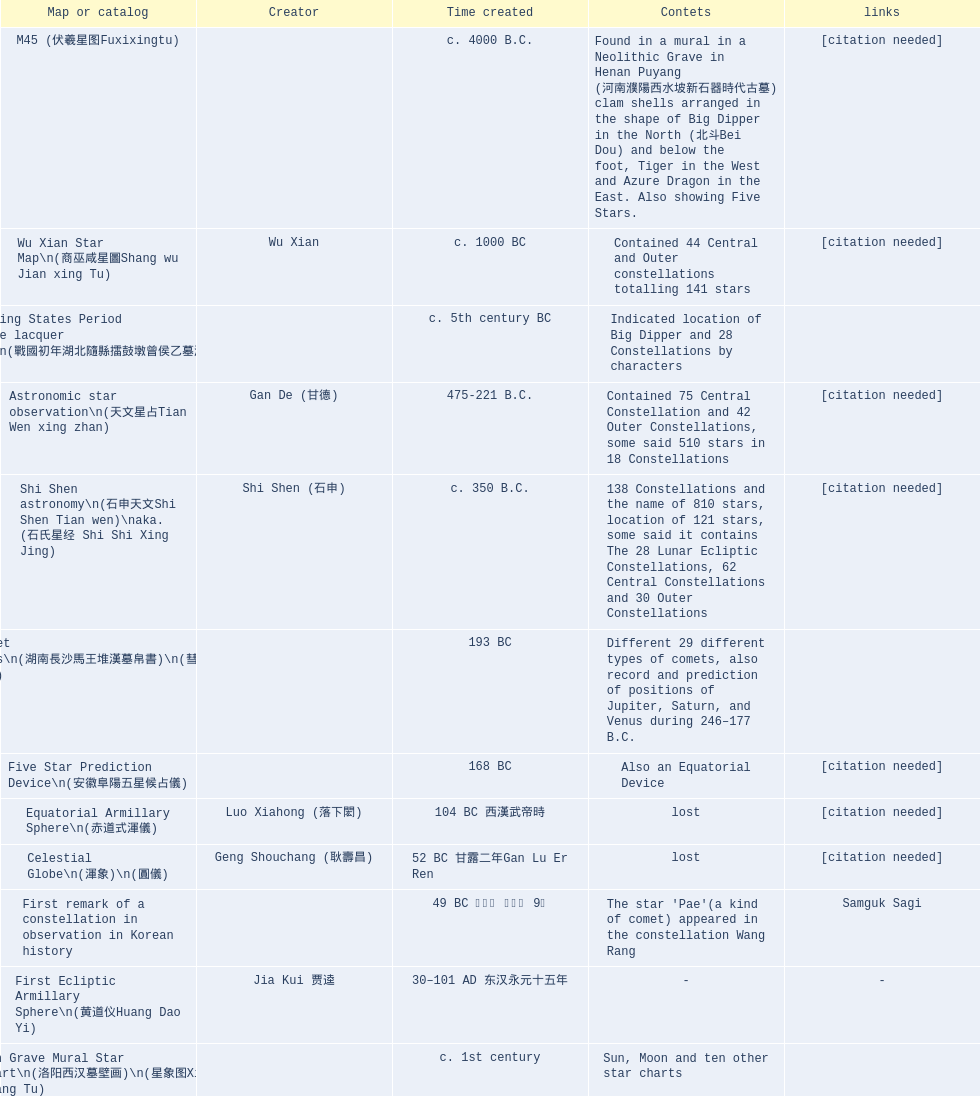Could you parse the entire table? {'header': ['Map or catalog', 'Creator', 'Time created', 'Contets', 'links'], 'rows': [['M45 (伏羲星图Fuxixingtu)', '', 'c. 4000 B.C.', 'Found in a mural in a Neolithic Grave in Henan Puyang (河南濮陽西水坡新石器時代古墓) clam shells arranged in the shape of Big Dipper in the North (北斗Bei Dou) and below the foot, Tiger in the West and Azure Dragon in the East. Also showing Five Stars.', '[citation needed]'], ['Wu Xian Star Map\\n(商巫咸星圖Shang wu Jian xing Tu)', 'Wu Xian', 'c. 1000 BC', 'Contained 44 Central and Outer constellations totalling 141 stars', '[citation needed]'], ['Warring States Period grave lacquer box\\n(戰國初年湖北隨縣擂鼓墩曾侯乙墓漆箱)', '', 'c. 5th century BC', 'Indicated location of Big Dipper and 28 Constellations by characters', ''], ['Astronomic star observation\\n(天文星占Tian Wen xing zhan)', 'Gan De (甘德)', '475-221 B.C.', 'Contained 75 Central Constellation and 42 Outer Constellations, some said 510 stars in 18 Constellations', '[citation needed]'], ['Shi Shen astronomy\\n(石申天文Shi Shen Tian wen)\\naka. (石氏星经 Shi Shi Xing Jing)', 'Shi Shen (石申)', 'c. 350 B.C.', '138 Constellations and the name of 810 stars, location of 121 stars, some said it contains The 28 Lunar Ecliptic Constellations, 62 Central Constellations and 30 Outer Constellations', '[citation needed]'], ['Han Comet Diagrams\\n(湖南長沙馬王堆漢墓帛書)\\n(彗星圖Meng xing Tu)', '', '193 BC', 'Different 29 different types of comets, also record and prediction of positions of Jupiter, Saturn, and Venus during 246–177 B.C.', ''], ['Five Star Prediction Device\\n(安徽阜陽五星候占儀)', '', '168 BC', 'Also an Equatorial Device', '[citation needed]'], ['Equatorial Armillary Sphere\\n(赤道式渾儀)', 'Luo Xiahong (落下閎)', '104 BC 西漢武帝時', 'lost', '[citation needed]'], ['Celestial Globe\\n(渾象)\\n(圓儀)', 'Geng Shouchang (耿壽昌)', '52 BC 甘露二年Gan Lu Er Ren', 'lost', '[citation needed]'], ['First remark of a constellation in observation in Korean history', '', '49 BC 혁거세 거서간 9년', "The star 'Pae'(a kind of comet) appeared in the constellation Wang Rang", 'Samguk Sagi'], ['First Ecliptic Armillary Sphere\\n(黄道仪Huang Dao Yi)', 'Jia Kui 贾逵', '30–101 AD 东汉永元十五年', '-', '-'], ['Han Grave Mural Star Chart\\n(洛阳西汉墓壁画)\\n(星象图Xing Xiang Tu)', '', 'c. 1st century', 'Sun, Moon and ten other star charts', ''], ['Han Dynasty Nanyang Stone Engraving\\n(河南南阳汉石刻画)\\n(行雨图Xing Yu Tu)', '', 'c. 1st century', 'Depicted five stars forming a cross', ''], ['Eastern Han Celestial Globe and star maps\\n(浑天仪)\\n(渾天儀圖注,浑天仪图注)\\n(靈憲,灵宪)', 'Zhang Heng (张衡)', '117 AD', '-', '-'], ['Sky Map\\n(浑天图)\\nand\\nHun Tian Yi Shuo\\n(浑天仪说)', 'Lu Ji (陆绩)', '187–219 AD 三国', '-', '-'], ['Reproduced Hun Tian Yi\\n(浑天仪)\\nand wrote\\nHun Tian Xiang Shuo\\n(浑天象说)', 'Wang Fan 王蕃', '227–266 AD 三国', '-', '-'], ['Whole Sky Star Maps\\n(全天星圖Quan Tian Xing Tu)', 'Chen Zhuo (陳卓)', 'c. 270 AD 西晉初Xi Jin Chu', 'A Unified Constellation System. Star maps containing 1464 stars in 284 Constellations, written astrology text', '-'], ['Equatorial Armillary Sphere\\n(渾儀Hun Xi)', 'Kong Ting (孔挺)', '323 AD 東晉 前趙光初六年', 'level being used in this kind of device', '-'], ['Northern Wei Period Iron Armillary Sphere\\n(鐵渾儀)', 'Hu Lan (斛蘭)', 'Bei Wei\\plevel being used in this kind of device', '-', ''], ['Southern Dynasties Period Whole Sky Planetarium\\n(渾天象Hun Tian Xiang)', 'Qian Lezhi (錢樂之)', '443 AD 南朝劉宋元嘉年間', 'used red, black and white to differentiate stars from different star maps from Shi Shen, Gan De and Wu Xian 甘, 石, 巫三家星', '-'], ['Northern Wei Grave Dome Star Map\\n(河南洛陽北魏墓頂星圖)', '', '526 AD 北魏孝昌二年', 'about 300 stars, including the Big Dipper, some stars are linked by straight lines to form constellation. The Milky Way is also shown.', ''], ['Water-powered Planetarium\\n(水力渾天儀)', 'Geng Xun (耿詢)', 'c. 7th century 隋初Sui Chu', '-', '-'], ['Lingtai Miyuan\\n(靈台秘苑)', 'Yu Jicai (庾季才) and Zhou Fen (周墳)', '604 AD 隋Sui', 'incorporated star maps from different sources', '-'], ['Tang Dynasty Whole Sky Ecliptic Armillary Sphere\\n(渾天黃道儀)', 'Li Chunfeng 李淳風', '667 AD 貞觀七年', 'including Elliptic and Moon orbit, in addition to old equatorial design', '-'], ['The Dunhuang star map\\n(燉煌)', 'Dun Huang', '705–710 AD', '1,585 stars grouped into 257 clusters or "asterisms"', ''], ['Turfan Tomb Star Mural\\n(新疆吐鲁番阿斯塔那天文壁画)', '', '250–799 AD 唐', '28 Constellations, Milkyway and Five Stars', ''], ['Picture of Fuxi and Nüwa 新疆阿斯達那唐墓伏羲Fu Xi 女媧NV Wa像Xiang', '', 'Tang Dynasty', 'Picture of Fuxi and Nuwa together with some constellations', 'Image:Nuva fuxi.gif'], ['Tang Dynasty Armillary Sphere\\n(唐代渾儀Tang Dai Hun Xi)\\n(黃道遊儀Huang dao you xi)', 'Yixing Monk 一行和尚 (张遂)Zhang Sui and Liang Lingzan 梁令瓚', '683–727 AD', 'based on Han Dynasty Celestial Globe, recalibrated locations of 150 stars, determined that stars are moving', ''], ['Tang Dynasty Indian Horoscope Chart\\n(梵天火羅九曜)', 'Yixing Priest 一行和尚 (张遂)\\pZhang Sui\\p683–727 AD', 'simple diagrams of the 28 Constellation', '', ''], ['Kitora Kofun 法隆寺FaLong Si\u3000キトラ古墳 in Japan', '', 'c. late 7th century – early 8th century', 'Detailed whole sky map', ''], ['Treatise on Astrology of the Kaiyuan Era\\n(開元占経,开元占经Kai Yuan zhang Jing)', 'Gautama Siddha', '713 AD –', 'Collection of the three old star charts from Shi Shen, Gan De and Wu Xian. One of the most renowned collection recognized academically.', '-'], ['Big Dipper\\n(山東嘉祥武梁寺石刻北斗星)', '', '–', 'showing stars in Big Dipper', ''], ['Prajvalonisa Vjrabhairava Padvinasa-sri-dharani Scroll found in Japan 熾盛光佛頂大威德銷災吉祥陀羅尼經卷首扉畫', '', '972 AD 北宋開寶五年', 'Chinese 28 Constellations and Western Zodiac', '-'], ['Tangut Khara-Khoto (The Black City) Star Map 西夏黑水城星圖', '', '940 AD', 'A typical Qian Lezhi Style Star Map', '-'], ['Star Chart 五代吳越文穆王前元瓘墓石刻星象圖', '', '941–960 AD', '-', ''], ['Ancient Star Map 先天图 by 陈抟Chen Tuan', '', 'c. 11th Chen Tuan 宋Song', 'Perhaps based on studying of Puyong Ancient Star Map', 'Lost'], ['Song Dynasty Bronze Armillary Sphere 北宋至道銅渾儀', 'Han Xianfu 韓顯符', '1006 AD 宋道元年十二月', 'Similar to the Simplified Armillary by Kong Ting 孔挺, 晁崇 Chao Chong, 斛蘭 Hu Lan', '-'], ['Song Dynasty Bronze Armillary Sphere 北宋天文院黄道渾儀', 'Shu Yijian 舒易簡, Yu Yuan 于渊, Zhou Cong 周琮', '宋皇祐年中', 'Similar to the Armillary by Tang Dynasty Liang Lingzan 梁令瓚 and Yi Xing 一行', '-'], ['Song Dynasty Armillary Sphere 北宋簡化渾儀', 'Shen Kuo 沈括 and Huangfu Yu 皇甫愈', '1089 AD 熙寧七年', 'Simplied version of Tang Dynasty Device, removed the rarely used moon orbit.', '-'], ['Five Star Charts (新儀象法要)', 'Su Song 蘇頌', '1094 AD', '1464 stars grouped into 283 asterisms', 'Image:Su Song Star Map 1.JPG\\nImage:Su Song Star Map 2.JPG'], ['Song Dynasty Water-powered Planetarium 宋代 水运仪象台', 'Su Song 蘇頌 and Han Gonglian 韩公廉', 'c. 11th century', '-', ''], ['Liao Dynasty Tomb Dome Star Map 遼宣化张世卿墓頂星圖', '', '1116 AD 遼天庆六年', 'shown both the Chinese 28 Constellation encircled by Babylonian Zodiac', ''], ["Star Map in a woman's grave (江西德安 南宋周氏墓星相图)", '', '1127–1279 AD', 'Milky Way and 57 other stars.', ''], ['Hun Tian Yi Tong Xing Xiang Quan Tu, Suzhou Star Chart (蘇州石刻天文圖),淳祐天文図', 'Huang Shang (黃裳)', 'created in 1193, etched to stone in 1247 by Wang Zhi Yuan 王致遠', '1434 Stars grouped into 280 Asterisms in Northern Sky map', ''], ['Yuan Dynasty Simplified Armillary Sphere 元代簡儀', 'Guo Shou Jing 郭守敬', '1276–1279', 'Further simplied version of Song Dynasty Device', ''], ['Japanese Star Chart 格子月進図', '', '1324', 'Similar to Su Song Star Chart, original burned in air raids during World War II, only pictures left. Reprinted in 1984 by 佐佐木英治', ''], ['天象列次分野之図(Cheonsang Yeolcha Bunyajido)', '', '1395', 'Korean versions of Star Map in Stone. It was made in Chosun Dynasty and the constellation names were written in Chinese letter. The constellations as this was found in Japanese later. Contained 1,464 stars.', ''], ['Japanese Star Chart 瀧谷寺 天之図', '', 'c. 14th or 15th centuries 室町中期以前', '-', ''], ["Korean King Sejong's Armillary sphere", '', '1433', '-', ''], ['Star Chart', 'Mao Kun 茅坤', 'c. 1422', 'Polaris compared with Southern Cross and Alpha Centauri', 'zh:郑和航海图'], ['Korean Tomb', '', 'c. late 14th century', 'Big Dipper', ''], ['Ming Ancient Star Chart 北京隆福寺(古星圖)', '', 'c. 1453 明代', '1420 Stars, possibly based on old star maps from Tang Dynasty', ''], ['Chanshu Star Chart (明常熟石刻天文圖)', '', '1506', 'Based on Suzhou Star Chart, Northern Sky observed at 36.8 degrees North Latitude, 1466 stars grouped into 284 asterism', '-'], ['Ming Dynasty Star Map (渾蓋通憲圖說)', 'Matteo Ricci 利玛窦Li Ma Dou, recorded by Li Zhizao 李之藻', 'c. 1550', '-', ''], ['Tian Wun Tu (天问图)', 'Xiao Yun Cong 萧云从', 'c. 1600', 'Contained mapping of 12 constellations and 12 animals', ''], ['Zhou Tian Xuan Ji Tu (周天璇玑图) and He He Si Xiang Tu (和合四象圖) in Xing Ming Gui Zhi (性命圭旨)', 'by 尹真人高第弟子 published by 余永宁', '1615', 'Drawings of Armillary Sphere and four Chinese Celestial Animals with some notes. Related to Taoism.', ''], ['Korean Astronomy Book "Selected and Systematized Astronomy Notes" 天文類抄', '', '1623~1649', 'Contained some star maps', ''], ['Ming Dynasty General Star Map (赤道南北兩總星圖)', 'Xu Guang ci 徐光啟 and Adam Schall von Bell Tang Ruo Wang湯若望', '1634', '-', ''], ['Ming Dynasty diagrams of Armillary spheres and Celestial Globes', 'Xu Guang ci 徐光啟', 'c. 1699', '-', ''], ['Ming Dynasty Planetarium Machine (渾象 Hui Xiang)', '', 'c. 17th century', 'Ecliptic, Equator, and dividers of 28 constellation', ''], ['Copper Plate Star Map stored in Korea', '', '1652 順治九年shun zi jiu nian', '-', ''], ['Japanese Edo period Star Chart 天象列次之図 based on 天象列次分野之図 from Korean', 'Harumi Shibukawa 渋川春海Bu Chuan Chun Mei(保井春海Bao Jing Chun Mei)', '1670 寛文十年', '-', ''], ['The Celestial Globe 清康熙 天體儀', 'Ferdinand Verbiest 南懷仁', '1673', '1876 stars grouped into 282 asterisms', ''], ['Picture depicted Song Dynasty fictional astronomer (呉用 Wu Yong) with a Celestial Globe (天體儀)', 'Japanese painter', '1675', 'showing top portion of a Celestial Globe', 'File:Chinese astronomer 1675.jpg'], ['Japanese Edo period Star Chart 天文分野之図', 'Harumi Shibukawa 渋川春海BuJingChun Mei (保井春海Bao JingChunMei)', '1677 延宝五年', '-', ''], ['Korean star map in stone', '', '1687', '-', ''], ['Japanese Edo period Star Chart 天文図解', '井口常範', '1689 元禄2年', '-', '-'], ['Japanese Edo period Star Chart 古暦便覧備考', '苗村丈伯Mao Chun Zhang Bo', '1692 元禄5年', '-', '-'], ['Japanese star chart', 'Harumi Yasui written in Chinese', '1699 AD', 'A Japanese star chart of 1699 showing lunar stations', ''], ['Japanese Edo period Star Chart 天文成象Tian Wen Cheng xiang', '(渋川昔尹She Chuan Xi Yin) (保井昔尹Bao Jing Xi Yin)', '1699 元禄十二年', 'including Stars from Wu Shien (44 Constellation, 144 stars) in yellow; Gan De (118 Constellations, 511 stars) in black; Shi Shen (138 Constellations, 810 stars) in red and Harumi Shibukawa (61 Constellations, 308 stars) in blue;', ''], ['Japanese Star Chart 改正天文図説', '', 'unknown', 'Included stars from Harumi Shibukawa', ''], ['Korean Star Map Stone', '', 'c. 17th century', '-', ''], ['Korean Star Map', '', 'c. 17th century', '-', ''], ['Ceramic Ink Sink Cover', '', 'c. 17th century', 'Showing Big Dipper', ''], ['Korean Star Map Cube 方星圖', 'Italian Missionary Philippus Maria Grimardi 閔明我 (1639~1712)', 'c. early 18th century', '-', ''], ['Star Chart preserved in Japan based on a book from China 天経或問', 'You Zi liu 游子六', '1730 AD 江戸時代 享保15年', 'A Northern Sky Chart in Chinese', ''], ['Star Chart 清蒙文石刻(欽天監繪製天文圖) in Mongolia', '', '1727–1732 AD', '1550 stars grouped into 270 starisms.', ''], ['Korean Star Maps, North and South to the Eclliptic 黃道南北恒星圖', '', '1742', '-', ''], ['Japanese Edo period Star Chart 天経或問註解図巻\u3000下', '入江脩敬Ru Jiang YOu Jing', '1750 寛延3年', '-', '-'], ['Reproduction of an ancient device 璇璣玉衡', 'Dai Zhen 戴震', '1723–1777 AD', 'based on ancient record and his own interpretation', 'Could be similar to'], ['Rock Star Chart 清代天文石', '', 'c. 18th century', 'A Star Chart and general Astronomy Text', ''], ['Korean Complete Star Map (渾天全圖)', '', 'c. 18th century', '-', ''], ['Qing Dynasty Star Catalog (儀象考成,仪象考成)恒星表 and Star Map 黄道南北両星総図', 'Yun Lu 允禄 and Ignatius Kogler 戴进贤Dai Jin Xian 戴進賢, a German', 'Device made in 1744, book completed in 1757 清乾隆年间', '300 Constellations and 3083 Stars. Referenced Star Catalogue published by John Flamsteed', ''], ['Jingban Tianwen Quantu by Ma Junliang 马俊良', '', '1780–90 AD', 'mapping nations to the sky', ''], ['Japanese Edo period Illustration of a Star Measuring Device 平天儀図解', 'Yan Qiao Shan Bing Heng 岩橋善兵衛', '1802 Xiang He Er Nian 享和二年', '-', 'The device could be similar to'], ['North Sky Map 清嘉庆年间Huang Dao Zhong Xi He Tu(黄道中西合图)', 'Xu Choujun 徐朝俊', '1807 AD', 'More than 1000 stars and the 28 consellation', ''], ['Japanese Edo period Star Chart 天象総星之図', 'Chao Ye Bei Shui 朝野北水', '1814 文化十一年', '-', '-'], ['Japanese Edo period Star Chart 新制天球星象記', '田中政均', '1815 文化十二年', '-', '-'], ['Japanese Edo period Star Chart 天球図', '坂部廣胖', '1816 文化十三年', '-', '-'], ['Chinese Star map', 'John Reeves esq', '1819 AD', 'Printed map showing Chinese names of stars and constellations', ''], ['Japanese Edo period Star Chart 昊天図説詳解', '佐藤祐之', '1824 文政七年', '-', '-'], ['Japanese Edo period Star Chart 星図歩天歌', '小島好謙 and 鈴木世孝', '1824 文政七年', '-', '-'], ['Japanese Edo period Star Chart', '鈴木世孝', '1824 文政七年', '-', '-'], ['Japanese Edo period Star Chart 天象管鈔 天体図 (天文星象図解)', '長久保赤水', '1824 文政七年', '-', ''], ['Japanese Edo period Star Measuring Device 中星儀', '足立信順Zhu Li Xin Shun', '1824 文政七年', '-', '-'], ['Japanese Star Map 天象一覧図 in Kanji', '桜田虎門', '1824 AD 文政７年', 'Printed map showing Chinese names of stars and constellations', ''], ['Korean Star Map 天象列次分野之図 in Kanji', '', 'c. 19th century', 'Printed map showing Chinese names of stars and constellations', '[18]'], ['Korean Star Map', '', 'c. 19th century, late Choson Period', '-', ''], ['Korean Star maps: Star Map South to the Ecliptic 黃道南恒星圖 and Star Map South to the Ecliptic 黃道北恒星圖', '', 'c. 19th century', 'Perhaps influenced by Adam Schall von Bell Tang Ruo wang 湯若望 (1591–1666) and P. Ignatius Koegler 戴進賢 (1680–1748)', ''], ['Korean Complete map of the celestial sphere (渾天全圖)', '', 'c. 19th century', '-', ''], ['Korean Book of Stars 經星', '', 'c. 19th century', 'Several star maps', ''], ['Japanese Edo period Star Chart 方円星図,方圓星図 and 増補分度星図方図', '石坂常堅', '1826b文政9年', '-', '-'], ['Japanese Star Chart', '伊能忠誨', 'c. 19th century', '-', '-'], ['Japanese Edo period Star Chart 天球図説', '古筆源了材', '1835 天保6年', '-', '-'], ['Qing Dynasty Star Catalog (儀象考成續編)星表', '', '1844', 'Appendix to Yi Xian Kao Cheng, listed 3240 stars (added 163, removed 6)', ''], ['Stars map (恒星赤道経緯度図)stored in Japan', '', '1844 道光24年 or 1848', '-', '-'], ['Japanese Edo period Star Chart 経緯簡儀用法', '藤岡有貞', '1845 弘化２年', '-', '-'], ['Japanese Edo period Star Chart 分野星図', '高塚福昌, 阿部比輔, 上条景弘', '1849 嘉永2年', '-', '-'], ['Japanese Late Edo period Star Chart 天文図屏風', '遠藤盛俊', 'late Edo Period 江戸時代後期', '-', '-'], ['Japanese Star Chart 天体図', '三浦梅園', '-', '-', '-'], ['Japanese Star Chart 梅園星図', '高橋景保', '-', '-', ''], ['Korean Book of New Song of the Sky Pacer 新法步天歌', '李俊養', '1862', 'Star maps and a revised version of the Song of Sky Pacer', ''], ['Stars South of Equator, Stars North of Equator (赤道南恆星圖,赤道北恆星圖)', '', '1875～1908 清末光緒年間', 'Similar to Ming Dynasty General Star Map', ''], ['Fuxi 64 gua 28 xu wood carving 天水市卦台山伏羲六十四卦二十八宿全图', '', 'modern', '-', '-'], ['Korean Map of Heaven and Earth 天地圖', '', 'c. 19th century', '28 Constellations and geographic map', ''], ['Korean version of 28 Constellation 列宿圖', '', 'c. 19th century', '28 Constellations, some named differently from their Chinese counterparts', ''], ['Korean Star Chart 渾天図', '朴?', '-', '-', '-'], ['Star Chart in a Dao Temple 玉皇山道觀星圖', '', '1940 AD', '-', '-'], ['Simplified Chinese and Western Star Map', 'Yi Shi Tong 伊世同', 'Aug. 1963', 'Star Map showing Chinese Xingquan and Western Constellation boundaries', ''], ['Sky Map', 'Yu Xi Dao Ren 玉溪道人', '1987', 'Star Map with captions', ''], ['The Chinese Sky during the Han Constellating Stars and Society', 'Sun Xiaochun and Jacob Kistemaker', '1997 AD', 'An attempt to recreate night sky seen by Chinese 2000 years ago', ''], ['Star map', '', 'Recent', 'An attempt by a Japanese to reconstruct the night sky for a historical event around 235 AD 秋風五丈原', ''], ['Star maps', '', 'Recent', 'Chinese 28 Constellation with Chinese and Japanese captions', ''], ['SinoSky Beta 2.0', '', '2002', 'A computer program capable of showing Chinese Xingguans alongside with western constellations, lists about 700 stars with Chinese names.', ''], ['AEEA Star maps', '', 'Modern', 'Good reconstruction and explanation of Chinese constellations', ''], ['Wikipedia Star maps', '', 'Modern', '-', 'zh:華蓋星'], ['28 Constellations, big dipper and 4 symbols Star map', '', 'Modern', '-', ''], ['Collection of printed star maps', '', 'Modern', '-', ''], ['28 Xu Star map and catalog', '-', 'Modern', 'Stars around ecliptic', ''], ['HNSKY Korean/Chinese Supplement', 'Jeong, Tae-Min(jtm71)/Chuang_Siau_Chin', 'Modern', 'Korean supplement is based on CheonSangYeulChaBunYaZiDo (B.C.100 ~ A.D.100)', ''], ['Stellarium Chinese and Korean Sky Culture', 'G.S.K. Lee; Jeong, Tae-Min(jtm71); Yu-Pu Wang (evanzxcv)', 'Modern', 'Major Xingguans and Star names', ''], ['修真內外火侯全圖 Huo Hou Tu', 'Xi Chun Sheng Chong Hui\\p2005 redrawn, original unknown', 'illustrations of Milkyway and star maps, Chinese constellations in Taoism view', '', ''], ['Star Map with illustrations for Xingguans', '坐井★观星Zuo Jing Guan Xing', 'Modern', 'illustrations for cylindrical and circular polar maps', ''], ['Sky in Google Earth KML', '', 'Modern', 'Attempts to show Chinese Star Maps on Google Earth', '']]} Between the celestial globe and the han grave mural star chart, which one was created earlier? Celestial Globe. 